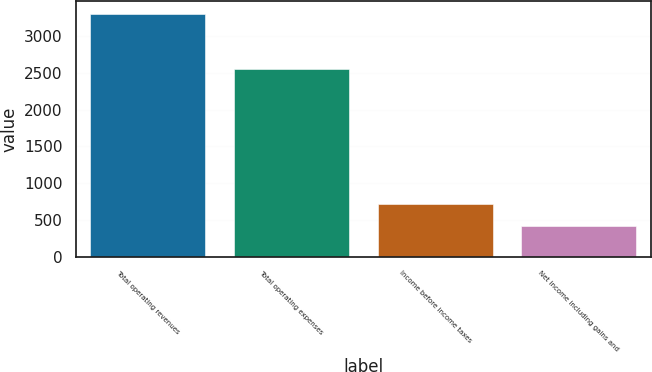Convert chart to OTSL. <chart><loc_0><loc_0><loc_500><loc_500><bar_chart><fcel>Total operating revenues<fcel>Total operating expenses<fcel>Income before income taxes<fcel>Net income including gains and<nl><fcel>3307.6<fcel>2559.8<fcel>709.66<fcel>421<nl></chart> 